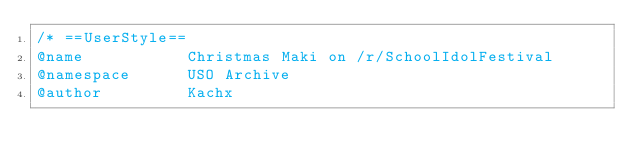<code> <loc_0><loc_0><loc_500><loc_500><_CSS_>/* ==UserStyle==
@name           Christmas Maki on /r/SchoolIdolFestival
@namespace      USO Archive
@author         Kachx</code> 